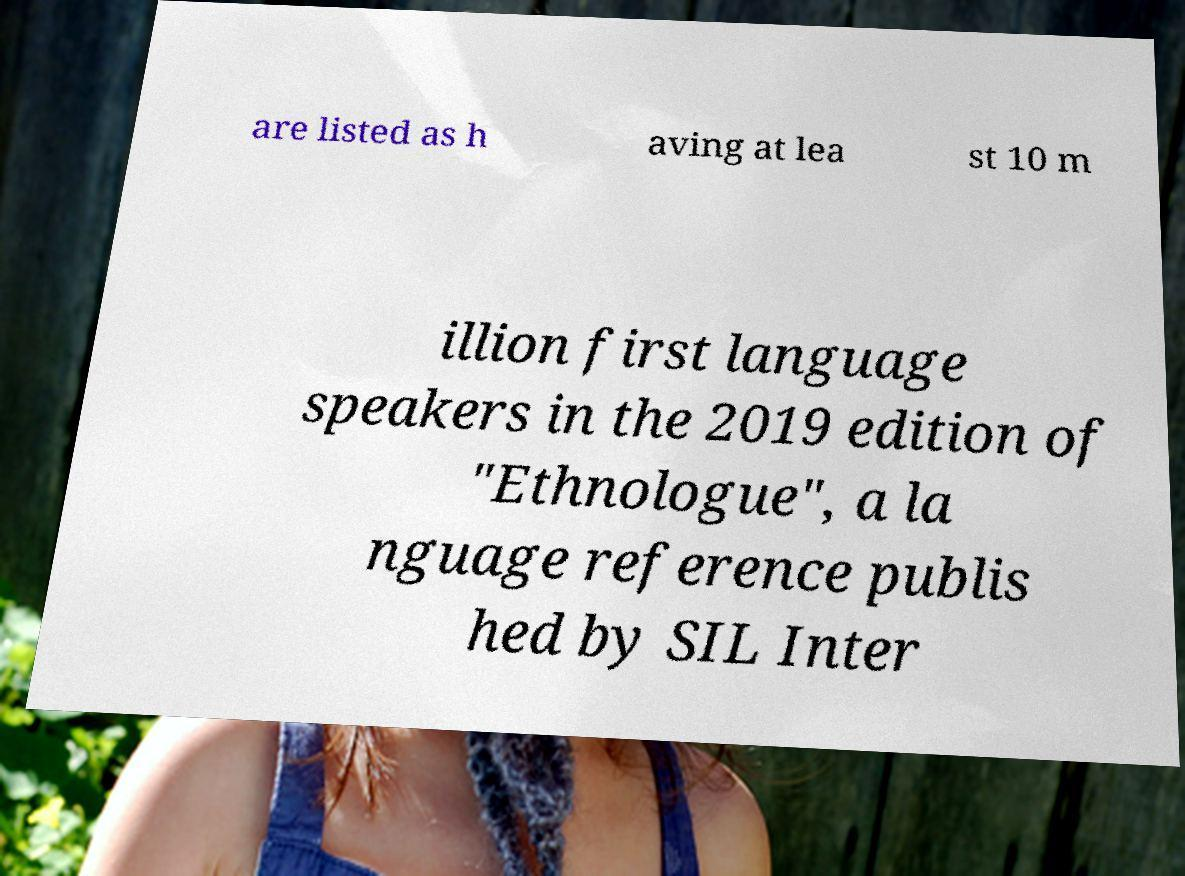For documentation purposes, I need the text within this image transcribed. Could you provide that? are listed as h aving at lea st 10 m illion first language speakers in the 2019 edition of "Ethnologue", a la nguage reference publis hed by SIL Inter 